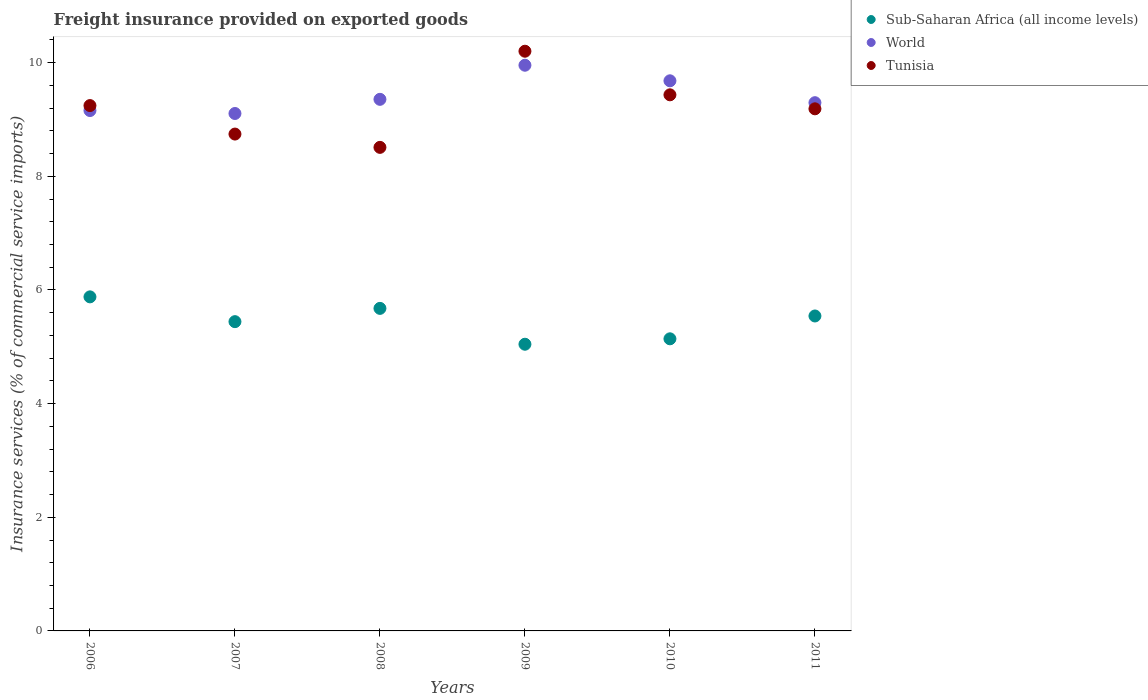What is the freight insurance provided on exported goods in Sub-Saharan Africa (all income levels) in 2006?
Your answer should be very brief. 5.88. Across all years, what is the maximum freight insurance provided on exported goods in Sub-Saharan Africa (all income levels)?
Your response must be concise. 5.88. Across all years, what is the minimum freight insurance provided on exported goods in World?
Your response must be concise. 9.11. In which year was the freight insurance provided on exported goods in Sub-Saharan Africa (all income levels) maximum?
Provide a succinct answer. 2006. What is the total freight insurance provided on exported goods in Tunisia in the graph?
Your response must be concise. 55.32. What is the difference between the freight insurance provided on exported goods in World in 2006 and that in 2009?
Ensure brevity in your answer.  -0.8. What is the difference between the freight insurance provided on exported goods in Tunisia in 2010 and the freight insurance provided on exported goods in Sub-Saharan Africa (all income levels) in 2009?
Offer a terse response. 4.39. What is the average freight insurance provided on exported goods in Sub-Saharan Africa (all income levels) per year?
Give a very brief answer. 5.45. In the year 2011, what is the difference between the freight insurance provided on exported goods in Sub-Saharan Africa (all income levels) and freight insurance provided on exported goods in World?
Offer a very short reply. -3.75. In how many years, is the freight insurance provided on exported goods in World greater than 4.8 %?
Ensure brevity in your answer.  6. What is the ratio of the freight insurance provided on exported goods in Sub-Saharan Africa (all income levels) in 2007 to that in 2008?
Keep it short and to the point. 0.96. What is the difference between the highest and the second highest freight insurance provided on exported goods in Sub-Saharan Africa (all income levels)?
Keep it short and to the point. 0.2. What is the difference between the highest and the lowest freight insurance provided on exported goods in Tunisia?
Ensure brevity in your answer.  1.69. In how many years, is the freight insurance provided on exported goods in Tunisia greater than the average freight insurance provided on exported goods in Tunisia taken over all years?
Your response must be concise. 3. Is the freight insurance provided on exported goods in Sub-Saharan Africa (all income levels) strictly greater than the freight insurance provided on exported goods in Tunisia over the years?
Your response must be concise. No. Is the freight insurance provided on exported goods in Sub-Saharan Africa (all income levels) strictly less than the freight insurance provided on exported goods in Tunisia over the years?
Your answer should be very brief. Yes. How many years are there in the graph?
Your answer should be compact. 6. What is the difference between two consecutive major ticks on the Y-axis?
Your response must be concise. 2. Where does the legend appear in the graph?
Provide a succinct answer. Top right. What is the title of the graph?
Your answer should be compact. Freight insurance provided on exported goods. What is the label or title of the X-axis?
Keep it short and to the point. Years. What is the label or title of the Y-axis?
Your answer should be compact. Insurance services (% of commercial service imports). What is the Insurance services (% of commercial service imports) of Sub-Saharan Africa (all income levels) in 2006?
Your response must be concise. 5.88. What is the Insurance services (% of commercial service imports) of World in 2006?
Provide a succinct answer. 9.16. What is the Insurance services (% of commercial service imports) of Tunisia in 2006?
Offer a very short reply. 9.25. What is the Insurance services (% of commercial service imports) of Sub-Saharan Africa (all income levels) in 2007?
Your answer should be very brief. 5.44. What is the Insurance services (% of commercial service imports) in World in 2007?
Ensure brevity in your answer.  9.11. What is the Insurance services (% of commercial service imports) in Tunisia in 2007?
Offer a terse response. 8.74. What is the Insurance services (% of commercial service imports) in Sub-Saharan Africa (all income levels) in 2008?
Provide a short and direct response. 5.68. What is the Insurance services (% of commercial service imports) in World in 2008?
Your answer should be compact. 9.36. What is the Insurance services (% of commercial service imports) in Tunisia in 2008?
Keep it short and to the point. 8.51. What is the Insurance services (% of commercial service imports) of Sub-Saharan Africa (all income levels) in 2009?
Ensure brevity in your answer.  5.05. What is the Insurance services (% of commercial service imports) in World in 2009?
Provide a succinct answer. 9.96. What is the Insurance services (% of commercial service imports) in Tunisia in 2009?
Offer a very short reply. 10.2. What is the Insurance services (% of commercial service imports) in Sub-Saharan Africa (all income levels) in 2010?
Ensure brevity in your answer.  5.14. What is the Insurance services (% of commercial service imports) of World in 2010?
Offer a very short reply. 9.68. What is the Insurance services (% of commercial service imports) of Tunisia in 2010?
Keep it short and to the point. 9.43. What is the Insurance services (% of commercial service imports) in Sub-Saharan Africa (all income levels) in 2011?
Your response must be concise. 5.54. What is the Insurance services (% of commercial service imports) in World in 2011?
Offer a very short reply. 9.3. What is the Insurance services (% of commercial service imports) of Tunisia in 2011?
Ensure brevity in your answer.  9.19. Across all years, what is the maximum Insurance services (% of commercial service imports) in Sub-Saharan Africa (all income levels)?
Keep it short and to the point. 5.88. Across all years, what is the maximum Insurance services (% of commercial service imports) of World?
Offer a terse response. 9.96. Across all years, what is the maximum Insurance services (% of commercial service imports) in Tunisia?
Give a very brief answer. 10.2. Across all years, what is the minimum Insurance services (% of commercial service imports) in Sub-Saharan Africa (all income levels)?
Offer a terse response. 5.05. Across all years, what is the minimum Insurance services (% of commercial service imports) of World?
Make the answer very short. 9.11. Across all years, what is the minimum Insurance services (% of commercial service imports) of Tunisia?
Provide a short and direct response. 8.51. What is the total Insurance services (% of commercial service imports) of Sub-Saharan Africa (all income levels) in the graph?
Offer a very short reply. 32.73. What is the total Insurance services (% of commercial service imports) in World in the graph?
Provide a succinct answer. 56.55. What is the total Insurance services (% of commercial service imports) in Tunisia in the graph?
Provide a succinct answer. 55.32. What is the difference between the Insurance services (% of commercial service imports) of Sub-Saharan Africa (all income levels) in 2006 and that in 2007?
Your answer should be compact. 0.44. What is the difference between the Insurance services (% of commercial service imports) in World in 2006 and that in 2007?
Keep it short and to the point. 0.05. What is the difference between the Insurance services (% of commercial service imports) of Tunisia in 2006 and that in 2007?
Keep it short and to the point. 0.5. What is the difference between the Insurance services (% of commercial service imports) in Sub-Saharan Africa (all income levels) in 2006 and that in 2008?
Your answer should be very brief. 0.2. What is the difference between the Insurance services (% of commercial service imports) of World in 2006 and that in 2008?
Ensure brevity in your answer.  -0.2. What is the difference between the Insurance services (% of commercial service imports) of Tunisia in 2006 and that in 2008?
Your answer should be very brief. 0.74. What is the difference between the Insurance services (% of commercial service imports) in Sub-Saharan Africa (all income levels) in 2006 and that in 2009?
Offer a terse response. 0.83. What is the difference between the Insurance services (% of commercial service imports) of World in 2006 and that in 2009?
Your answer should be compact. -0.8. What is the difference between the Insurance services (% of commercial service imports) of Tunisia in 2006 and that in 2009?
Your answer should be compact. -0.96. What is the difference between the Insurance services (% of commercial service imports) of Sub-Saharan Africa (all income levels) in 2006 and that in 2010?
Your answer should be compact. 0.74. What is the difference between the Insurance services (% of commercial service imports) in World in 2006 and that in 2010?
Offer a terse response. -0.52. What is the difference between the Insurance services (% of commercial service imports) of Tunisia in 2006 and that in 2010?
Your answer should be compact. -0.19. What is the difference between the Insurance services (% of commercial service imports) of Sub-Saharan Africa (all income levels) in 2006 and that in 2011?
Your response must be concise. 0.34. What is the difference between the Insurance services (% of commercial service imports) in World in 2006 and that in 2011?
Your answer should be compact. -0.14. What is the difference between the Insurance services (% of commercial service imports) of Tunisia in 2006 and that in 2011?
Your answer should be very brief. 0.06. What is the difference between the Insurance services (% of commercial service imports) in Sub-Saharan Africa (all income levels) in 2007 and that in 2008?
Your answer should be compact. -0.23. What is the difference between the Insurance services (% of commercial service imports) in World in 2007 and that in 2008?
Provide a short and direct response. -0.25. What is the difference between the Insurance services (% of commercial service imports) in Tunisia in 2007 and that in 2008?
Give a very brief answer. 0.23. What is the difference between the Insurance services (% of commercial service imports) in Sub-Saharan Africa (all income levels) in 2007 and that in 2009?
Your answer should be very brief. 0.4. What is the difference between the Insurance services (% of commercial service imports) of World in 2007 and that in 2009?
Ensure brevity in your answer.  -0.85. What is the difference between the Insurance services (% of commercial service imports) in Tunisia in 2007 and that in 2009?
Ensure brevity in your answer.  -1.46. What is the difference between the Insurance services (% of commercial service imports) of Sub-Saharan Africa (all income levels) in 2007 and that in 2010?
Offer a very short reply. 0.3. What is the difference between the Insurance services (% of commercial service imports) of World in 2007 and that in 2010?
Offer a terse response. -0.58. What is the difference between the Insurance services (% of commercial service imports) of Tunisia in 2007 and that in 2010?
Your answer should be very brief. -0.69. What is the difference between the Insurance services (% of commercial service imports) in Sub-Saharan Africa (all income levels) in 2007 and that in 2011?
Provide a succinct answer. -0.1. What is the difference between the Insurance services (% of commercial service imports) in World in 2007 and that in 2011?
Offer a terse response. -0.19. What is the difference between the Insurance services (% of commercial service imports) in Tunisia in 2007 and that in 2011?
Provide a succinct answer. -0.44. What is the difference between the Insurance services (% of commercial service imports) of Sub-Saharan Africa (all income levels) in 2008 and that in 2009?
Offer a very short reply. 0.63. What is the difference between the Insurance services (% of commercial service imports) of World in 2008 and that in 2009?
Offer a very short reply. -0.6. What is the difference between the Insurance services (% of commercial service imports) of Tunisia in 2008 and that in 2009?
Provide a succinct answer. -1.69. What is the difference between the Insurance services (% of commercial service imports) of Sub-Saharan Africa (all income levels) in 2008 and that in 2010?
Keep it short and to the point. 0.54. What is the difference between the Insurance services (% of commercial service imports) in World in 2008 and that in 2010?
Give a very brief answer. -0.33. What is the difference between the Insurance services (% of commercial service imports) of Tunisia in 2008 and that in 2010?
Make the answer very short. -0.92. What is the difference between the Insurance services (% of commercial service imports) of Sub-Saharan Africa (all income levels) in 2008 and that in 2011?
Keep it short and to the point. 0.13. What is the difference between the Insurance services (% of commercial service imports) in World in 2008 and that in 2011?
Provide a succinct answer. 0.06. What is the difference between the Insurance services (% of commercial service imports) of Tunisia in 2008 and that in 2011?
Your response must be concise. -0.68. What is the difference between the Insurance services (% of commercial service imports) of Sub-Saharan Africa (all income levels) in 2009 and that in 2010?
Make the answer very short. -0.1. What is the difference between the Insurance services (% of commercial service imports) in World in 2009 and that in 2010?
Your answer should be very brief. 0.27. What is the difference between the Insurance services (% of commercial service imports) in Tunisia in 2009 and that in 2010?
Give a very brief answer. 0.77. What is the difference between the Insurance services (% of commercial service imports) of Sub-Saharan Africa (all income levels) in 2009 and that in 2011?
Make the answer very short. -0.5. What is the difference between the Insurance services (% of commercial service imports) in World in 2009 and that in 2011?
Give a very brief answer. 0.66. What is the difference between the Insurance services (% of commercial service imports) in Tunisia in 2009 and that in 2011?
Make the answer very short. 1.01. What is the difference between the Insurance services (% of commercial service imports) in Sub-Saharan Africa (all income levels) in 2010 and that in 2011?
Give a very brief answer. -0.4. What is the difference between the Insurance services (% of commercial service imports) in World in 2010 and that in 2011?
Ensure brevity in your answer.  0.39. What is the difference between the Insurance services (% of commercial service imports) of Tunisia in 2010 and that in 2011?
Keep it short and to the point. 0.25. What is the difference between the Insurance services (% of commercial service imports) of Sub-Saharan Africa (all income levels) in 2006 and the Insurance services (% of commercial service imports) of World in 2007?
Keep it short and to the point. -3.23. What is the difference between the Insurance services (% of commercial service imports) of Sub-Saharan Africa (all income levels) in 2006 and the Insurance services (% of commercial service imports) of Tunisia in 2007?
Make the answer very short. -2.87. What is the difference between the Insurance services (% of commercial service imports) of World in 2006 and the Insurance services (% of commercial service imports) of Tunisia in 2007?
Offer a terse response. 0.41. What is the difference between the Insurance services (% of commercial service imports) of Sub-Saharan Africa (all income levels) in 2006 and the Insurance services (% of commercial service imports) of World in 2008?
Provide a short and direct response. -3.48. What is the difference between the Insurance services (% of commercial service imports) of Sub-Saharan Africa (all income levels) in 2006 and the Insurance services (% of commercial service imports) of Tunisia in 2008?
Offer a terse response. -2.63. What is the difference between the Insurance services (% of commercial service imports) in World in 2006 and the Insurance services (% of commercial service imports) in Tunisia in 2008?
Keep it short and to the point. 0.65. What is the difference between the Insurance services (% of commercial service imports) in Sub-Saharan Africa (all income levels) in 2006 and the Insurance services (% of commercial service imports) in World in 2009?
Make the answer very short. -4.08. What is the difference between the Insurance services (% of commercial service imports) in Sub-Saharan Africa (all income levels) in 2006 and the Insurance services (% of commercial service imports) in Tunisia in 2009?
Provide a short and direct response. -4.32. What is the difference between the Insurance services (% of commercial service imports) of World in 2006 and the Insurance services (% of commercial service imports) of Tunisia in 2009?
Offer a terse response. -1.04. What is the difference between the Insurance services (% of commercial service imports) in Sub-Saharan Africa (all income levels) in 2006 and the Insurance services (% of commercial service imports) in World in 2010?
Make the answer very short. -3.8. What is the difference between the Insurance services (% of commercial service imports) of Sub-Saharan Africa (all income levels) in 2006 and the Insurance services (% of commercial service imports) of Tunisia in 2010?
Ensure brevity in your answer.  -3.56. What is the difference between the Insurance services (% of commercial service imports) in World in 2006 and the Insurance services (% of commercial service imports) in Tunisia in 2010?
Offer a very short reply. -0.28. What is the difference between the Insurance services (% of commercial service imports) of Sub-Saharan Africa (all income levels) in 2006 and the Insurance services (% of commercial service imports) of World in 2011?
Provide a succinct answer. -3.42. What is the difference between the Insurance services (% of commercial service imports) in Sub-Saharan Africa (all income levels) in 2006 and the Insurance services (% of commercial service imports) in Tunisia in 2011?
Your answer should be very brief. -3.31. What is the difference between the Insurance services (% of commercial service imports) in World in 2006 and the Insurance services (% of commercial service imports) in Tunisia in 2011?
Ensure brevity in your answer.  -0.03. What is the difference between the Insurance services (% of commercial service imports) in Sub-Saharan Africa (all income levels) in 2007 and the Insurance services (% of commercial service imports) in World in 2008?
Keep it short and to the point. -3.91. What is the difference between the Insurance services (% of commercial service imports) in Sub-Saharan Africa (all income levels) in 2007 and the Insurance services (% of commercial service imports) in Tunisia in 2008?
Provide a succinct answer. -3.07. What is the difference between the Insurance services (% of commercial service imports) in World in 2007 and the Insurance services (% of commercial service imports) in Tunisia in 2008?
Make the answer very short. 0.6. What is the difference between the Insurance services (% of commercial service imports) of Sub-Saharan Africa (all income levels) in 2007 and the Insurance services (% of commercial service imports) of World in 2009?
Your response must be concise. -4.51. What is the difference between the Insurance services (% of commercial service imports) of Sub-Saharan Africa (all income levels) in 2007 and the Insurance services (% of commercial service imports) of Tunisia in 2009?
Keep it short and to the point. -4.76. What is the difference between the Insurance services (% of commercial service imports) of World in 2007 and the Insurance services (% of commercial service imports) of Tunisia in 2009?
Offer a very short reply. -1.1. What is the difference between the Insurance services (% of commercial service imports) in Sub-Saharan Africa (all income levels) in 2007 and the Insurance services (% of commercial service imports) in World in 2010?
Make the answer very short. -4.24. What is the difference between the Insurance services (% of commercial service imports) of Sub-Saharan Africa (all income levels) in 2007 and the Insurance services (% of commercial service imports) of Tunisia in 2010?
Your answer should be very brief. -3.99. What is the difference between the Insurance services (% of commercial service imports) in World in 2007 and the Insurance services (% of commercial service imports) in Tunisia in 2010?
Your answer should be compact. -0.33. What is the difference between the Insurance services (% of commercial service imports) in Sub-Saharan Africa (all income levels) in 2007 and the Insurance services (% of commercial service imports) in World in 2011?
Provide a succinct answer. -3.85. What is the difference between the Insurance services (% of commercial service imports) in Sub-Saharan Africa (all income levels) in 2007 and the Insurance services (% of commercial service imports) in Tunisia in 2011?
Make the answer very short. -3.75. What is the difference between the Insurance services (% of commercial service imports) in World in 2007 and the Insurance services (% of commercial service imports) in Tunisia in 2011?
Ensure brevity in your answer.  -0.08. What is the difference between the Insurance services (% of commercial service imports) of Sub-Saharan Africa (all income levels) in 2008 and the Insurance services (% of commercial service imports) of World in 2009?
Provide a succinct answer. -4.28. What is the difference between the Insurance services (% of commercial service imports) of Sub-Saharan Africa (all income levels) in 2008 and the Insurance services (% of commercial service imports) of Tunisia in 2009?
Give a very brief answer. -4.53. What is the difference between the Insurance services (% of commercial service imports) in World in 2008 and the Insurance services (% of commercial service imports) in Tunisia in 2009?
Provide a short and direct response. -0.85. What is the difference between the Insurance services (% of commercial service imports) in Sub-Saharan Africa (all income levels) in 2008 and the Insurance services (% of commercial service imports) in World in 2010?
Give a very brief answer. -4.01. What is the difference between the Insurance services (% of commercial service imports) of Sub-Saharan Africa (all income levels) in 2008 and the Insurance services (% of commercial service imports) of Tunisia in 2010?
Your response must be concise. -3.76. What is the difference between the Insurance services (% of commercial service imports) of World in 2008 and the Insurance services (% of commercial service imports) of Tunisia in 2010?
Provide a short and direct response. -0.08. What is the difference between the Insurance services (% of commercial service imports) in Sub-Saharan Africa (all income levels) in 2008 and the Insurance services (% of commercial service imports) in World in 2011?
Ensure brevity in your answer.  -3.62. What is the difference between the Insurance services (% of commercial service imports) of Sub-Saharan Africa (all income levels) in 2008 and the Insurance services (% of commercial service imports) of Tunisia in 2011?
Offer a terse response. -3.51. What is the difference between the Insurance services (% of commercial service imports) of World in 2008 and the Insurance services (% of commercial service imports) of Tunisia in 2011?
Ensure brevity in your answer.  0.17. What is the difference between the Insurance services (% of commercial service imports) in Sub-Saharan Africa (all income levels) in 2009 and the Insurance services (% of commercial service imports) in World in 2010?
Provide a succinct answer. -4.64. What is the difference between the Insurance services (% of commercial service imports) of Sub-Saharan Africa (all income levels) in 2009 and the Insurance services (% of commercial service imports) of Tunisia in 2010?
Your answer should be very brief. -4.39. What is the difference between the Insurance services (% of commercial service imports) in World in 2009 and the Insurance services (% of commercial service imports) in Tunisia in 2010?
Make the answer very short. 0.52. What is the difference between the Insurance services (% of commercial service imports) of Sub-Saharan Africa (all income levels) in 2009 and the Insurance services (% of commercial service imports) of World in 2011?
Give a very brief answer. -4.25. What is the difference between the Insurance services (% of commercial service imports) in Sub-Saharan Africa (all income levels) in 2009 and the Insurance services (% of commercial service imports) in Tunisia in 2011?
Provide a succinct answer. -4.14. What is the difference between the Insurance services (% of commercial service imports) of World in 2009 and the Insurance services (% of commercial service imports) of Tunisia in 2011?
Offer a terse response. 0.77. What is the difference between the Insurance services (% of commercial service imports) in Sub-Saharan Africa (all income levels) in 2010 and the Insurance services (% of commercial service imports) in World in 2011?
Offer a very short reply. -4.16. What is the difference between the Insurance services (% of commercial service imports) in Sub-Saharan Africa (all income levels) in 2010 and the Insurance services (% of commercial service imports) in Tunisia in 2011?
Your answer should be very brief. -4.05. What is the difference between the Insurance services (% of commercial service imports) of World in 2010 and the Insurance services (% of commercial service imports) of Tunisia in 2011?
Your response must be concise. 0.49. What is the average Insurance services (% of commercial service imports) in Sub-Saharan Africa (all income levels) per year?
Make the answer very short. 5.45. What is the average Insurance services (% of commercial service imports) in World per year?
Make the answer very short. 9.43. What is the average Insurance services (% of commercial service imports) in Tunisia per year?
Offer a very short reply. 9.22. In the year 2006, what is the difference between the Insurance services (% of commercial service imports) of Sub-Saharan Africa (all income levels) and Insurance services (% of commercial service imports) of World?
Provide a succinct answer. -3.28. In the year 2006, what is the difference between the Insurance services (% of commercial service imports) of Sub-Saharan Africa (all income levels) and Insurance services (% of commercial service imports) of Tunisia?
Make the answer very short. -3.37. In the year 2006, what is the difference between the Insurance services (% of commercial service imports) of World and Insurance services (% of commercial service imports) of Tunisia?
Your answer should be compact. -0.09. In the year 2007, what is the difference between the Insurance services (% of commercial service imports) in Sub-Saharan Africa (all income levels) and Insurance services (% of commercial service imports) in World?
Offer a terse response. -3.66. In the year 2007, what is the difference between the Insurance services (% of commercial service imports) in Sub-Saharan Africa (all income levels) and Insurance services (% of commercial service imports) in Tunisia?
Your response must be concise. -3.3. In the year 2007, what is the difference between the Insurance services (% of commercial service imports) of World and Insurance services (% of commercial service imports) of Tunisia?
Make the answer very short. 0.36. In the year 2008, what is the difference between the Insurance services (% of commercial service imports) of Sub-Saharan Africa (all income levels) and Insurance services (% of commercial service imports) of World?
Your answer should be very brief. -3.68. In the year 2008, what is the difference between the Insurance services (% of commercial service imports) in Sub-Saharan Africa (all income levels) and Insurance services (% of commercial service imports) in Tunisia?
Your answer should be very brief. -2.83. In the year 2008, what is the difference between the Insurance services (% of commercial service imports) of World and Insurance services (% of commercial service imports) of Tunisia?
Your answer should be very brief. 0.85. In the year 2009, what is the difference between the Insurance services (% of commercial service imports) in Sub-Saharan Africa (all income levels) and Insurance services (% of commercial service imports) in World?
Provide a succinct answer. -4.91. In the year 2009, what is the difference between the Insurance services (% of commercial service imports) in Sub-Saharan Africa (all income levels) and Insurance services (% of commercial service imports) in Tunisia?
Make the answer very short. -5.16. In the year 2009, what is the difference between the Insurance services (% of commercial service imports) of World and Insurance services (% of commercial service imports) of Tunisia?
Offer a very short reply. -0.25. In the year 2010, what is the difference between the Insurance services (% of commercial service imports) in Sub-Saharan Africa (all income levels) and Insurance services (% of commercial service imports) in World?
Offer a very short reply. -4.54. In the year 2010, what is the difference between the Insurance services (% of commercial service imports) of Sub-Saharan Africa (all income levels) and Insurance services (% of commercial service imports) of Tunisia?
Keep it short and to the point. -4.29. In the year 2010, what is the difference between the Insurance services (% of commercial service imports) in World and Insurance services (% of commercial service imports) in Tunisia?
Make the answer very short. 0.25. In the year 2011, what is the difference between the Insurance services (% of commercial service imports) of Sub-Saharan Africa (all income levels) and Insurance services (% of commercial service imports) of World?
Provide a short and direct response. -3.75. In the year 2011, what is the difference between the Insurance services (% of commercial service imports) in Sub-Saharan Africa (all income levels) and Insurance services (% of commercial service imports) in Tunisia?
Provide a succinct answer. -3.65. In the year 2011, what is the difference between the Insurance services (% of commercial service imports) in World and Insurance services (% of commercial service imports) in Tunisia?
Give a very brief answer. 0.11. What is the ratio of the Insurance services (% of commercial service imports) in Sub-Saharan Africa (all income levels) in 2006 to that in 2007?
Your answer should be very brief. 1.08. What is the ratio of the Insurance services (% of commercial service imports) in World in 2006 to that in 2007?
Provide a short and direct response. 1.01. What is the ratio of the Insurance services (% of commercial service imports) of Tunisia in 2006 to that in 2007?
Your response must be concise. 1.06. What is the ratio of the Insurance services (% of commercial service imports) of Sub-Saharan Africa (all income levels) in 2006 to that in 2008?
Your response must be concise. 1.04. What is the ratio of the Insurance services (% of commercial service imports) in World in 2006 to that in 2008?
Your answer should be very brief. 0.98. What is the ratio of the Insurance services (% of commercial service imports) in Tunisia in 2006 to that in 2008?
Your answer should be compact. 1.09. What is the ratio of the Insurance services (% of commercial service imports) in Sub-Saharan Africa (all income levels) in 2006 to that in 2009?
Offer a very short reply. 1.17. What is the ratio of the Insurance services (% of commercial service imports) in World in 2006 to that in 2009?
Ensure brevity in your answer.  0.92. What is the ratio of the Insurance services (% of commercial service imports) of Tunisia in 2006 to that in 2009?
Your answer should be very brief. 0.91. What is the ratio of the Insurance services (% of commercial service imports) of Sub-Saharan Africa (all income levels) in 2006 to that in 2010?
Your response must be concise. 1.14. What is the ratio of the Insurance services (% of commercial service imports) of World in 2006 to that in 2010?
Offer a very short reply. 0.95. What is the ratio of the Insurance services (% of commercial service imports) of Tunisia in 2006 to that in 2010?
Your answer should be very brief. 0.98. What is the ratio of the Insurance services (% of commercial service imports) of Sub-Saharan Africa (all income levels) in 2006 to that in 2011?
Give a very brief answer. 1.06. What is the ratio of the Insurance services (% of commercial service imports) of World in 2006 to that in 2011?
Your answer should be compact. 0.99. What is the ratio of the Insurance services (% of commercial service imports) in Tunisia in 2006 to that in 2011?
Offer a terse response. 1.01. What is the ratio of the Insurance services (% of commercial service imports) of Sub-Saharan Africa (all income levels) in 2007 to that in 2008?
Provide a short and direct response. 0.96. What is the ratio of the Insurance services (% of commercial service imports) in World in 2007 to that in 2008?
Your answer should be very brief. 0.97. What is the ratio of the Insurance services (% of commercial service imports) of Tunisia in 2007 to that in 2008?
Your answer should be compact. 1.03. What is the ratio of the Insurance services (% of commercial service imports) of Sub-Saharan Africa (all income levels) in 2007 to that in 2009?
Provide a succinct answer. 1.08. What is the ratio of the Insurance services (% of commercial service imports) of World in 2007 to that in 2009?
Keep it short and to the point. 0.91. What is the ratio of the Insurance services (% of commercial service imports) in Sub-Saharan Africa (all income levels) in 2007 to that in 2010?
Give a very brief answer. 1.06. What is the ratio of the Insurance services (% of commercial service imports) in World in 2007 to that in 2010?
Your answer should be very brief. 0.94. What is the ratio of the Insurance services (% of commercial service imports) in Tunisia in 2007 to that in 2010?
Ensure brevity in your answer.  0.93. What is the ratio of the Insurance services (% of commercial service imports) of World in 2007 to that in 2011?
Make the answer very short. 0.98. What is the ratio of the Insurance services (% of commercial service imports) in Tunisia in 2007 to that in 2011?
Ensure brevity in your answer.  0.95. What is the ratio of the Insurance services (% of commercial service imports) of Sub-Saharan Africa (all income levels) in 2008 to that in 2009?
Ensure brevity in your answer.  1.13. What is the ratio of the Insurance services (% of commercial service imports) in World in 2008 to that in 2009?
Your answer should be compact. 0.94. What is the ratio of the Insurance services (% of commercial service imports) in Tunisia in 2008 to that in 2009?
Your answer should be very brief. 0.83. What is the ratio of the Insurance services (% of commercial service imports) in Sub-Saharan Africa (all income levels) in 2008 to that in 2010?
Ensure brevity in your answer.  1.1. What is the ratio of the Insurance services (% of commercial service imports) in World in 2008 to that in 2010?
Your answer should be compact. 0.97. What is the ratio of the Insurance services (% of commercial service imports) of Tunisia in 2008 to that in 2010?
Ensure brevity in your answer.  0.9. What is the ratio of the Insurance services (% of commercial service imports) in Sub-Saharan Africa (all income levels) in 2008 to that in 2011?
Give a very brief answer. 1.02. What is the ratio of the Insurance services (% of commercial service imports) in World in 2008 to that in 2011?
Ensure brevity in your answer.  1.01. What is the ratio of the Insurance services (% of commercial service imports) of Tunisia in 2008 to that in 2011?
Your response must be concise. 0.93. What is the ratio of the Insurance services (% of commercial service imports) of Sub-Saharan Africa (all income levels) in 2009 to that in 2010?
Offer a terse response. 0.98. What is the ratio of the Insurance services (% of commercial service imports) of World in 2009 to that in 2010?
Your answer should be very brief. 1.03. What is the ratio of the Insurance services (% of commercial service imports) in Tunisia in 2009 to that in 2010?
Provide a short and direct response. 1.08. What is the ratio of the Insurance services (% of commercial service imports) in Sub-Saharan Africa (all income levels) in 2009 to that in 2011?
Your answer should be very brief. 0.91. What is the ratio of the Insurance services (% of commercial service imports) in World in 2009 to that in 2011?
Your response must be concise. 1.07. What is the ratio of the Insurance services (% of commercial service imports) of Tunisia in 2009 to that in 2011?
Offer a terse response. 1.11. What is the ratio of the Insurance services (% of commercial service imports) in Sub-Saharan Africa (all income levels) in 2010 to that in 2011?
Provide a succinct answer. 0.93. What is the ratio of the Insurance services (% of commercial service imports) of World in 2010 to that in 2011?
Provide a succinct answer. 1.04. What is the ratio of the Insurance services (% of commercial service imports) of Tunisia in 2010 to that in 2011?
Make the answer very short. 1.03. What is the difference between the highest and the second highest Insurance services (% of commercial service imports) in Sub-Saharan Africa (all income levels)?
Ensure brevity in your answer.  0.2. What is the difference between the highest and the second highest Insurance services (% of commercial service imports) of World?
Your response must be concise. 0.27. What is the difference between the highest and the second highest Insurance services (% of commercial service imports) of Tunisia?
Give a very brief answer. 0.77. What is the difference between the highest and the lowest Insurance services (% of commercial service imports) of Sub-Saharan Africa (all income levels)?
Make the answer very short. 0.83. What is the difference between the highest and the lowest Insurance services (% of commercial service imports) in World?
Keep it short and to the point. 0.85. What is the difference between the highest and the lowest Insurance services (% of commercial service imports) of Tunisia?
Keep it short and to the point. 1.69. 